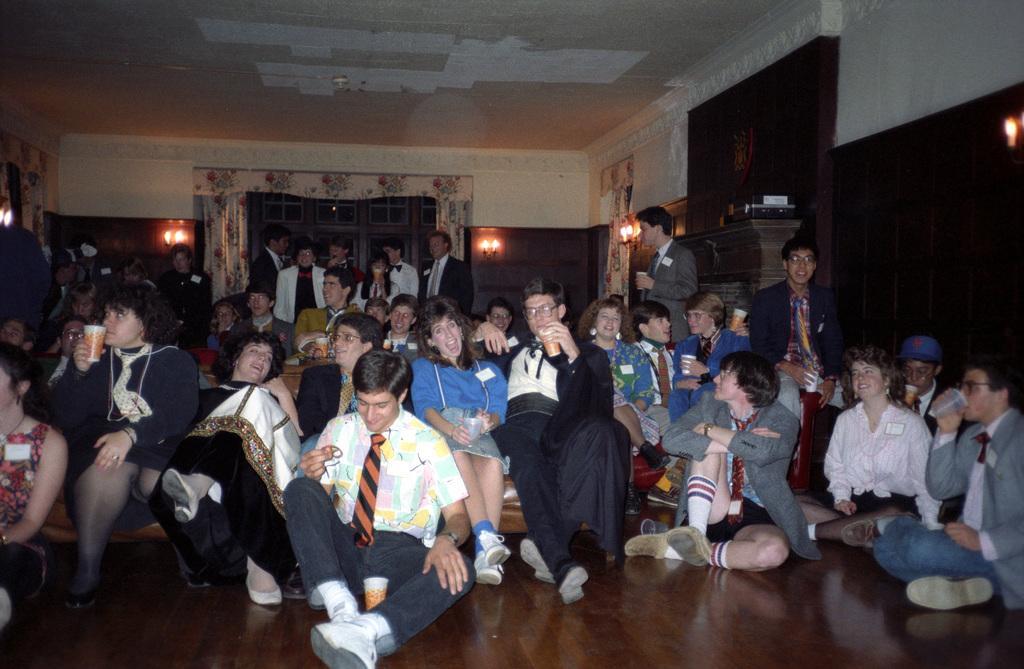Could you give a brief overview of what you see in this image? In this picture we can see some people are sitting in the front, in the background there are some people standing, at the bottom there is floor, we can see lights, curtains, windows and a wall in the background, we can see the ceiling at the top of the picture. 